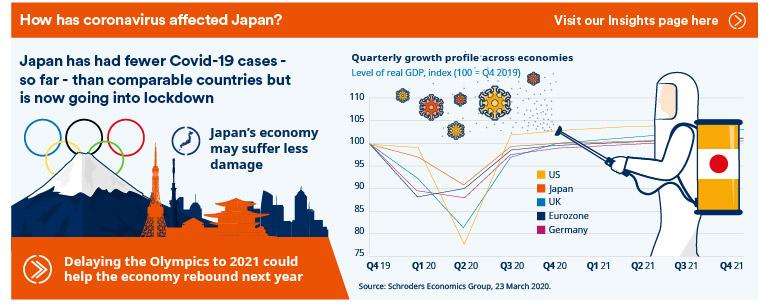Indicate a few pertinent items in this graphic. The country with the lowest GDP in the second quarter of 2020 was the United States. According to the latest report, the United Kingdom had the second lowest GDP in the second quarter of 2020. The rebound of Japan's economy can be achieved by delaying the Olympics to 2021, as this would provide additional time for necessary economic and infrastructure preparations, ultimately leading to a more successful and sustainable event. Japan is the country that experienced the smallest decrease in GDP in the second quarter of 2020. 